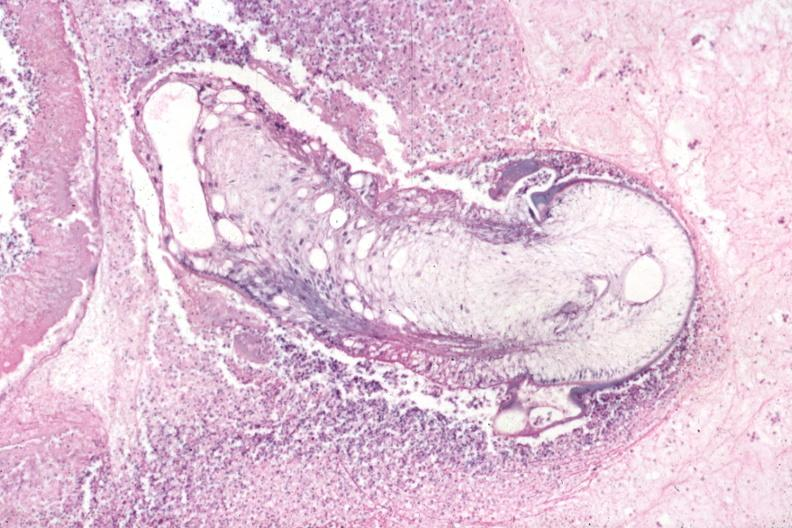s eye present?
Answer the question using a single word or phrase. Yes 